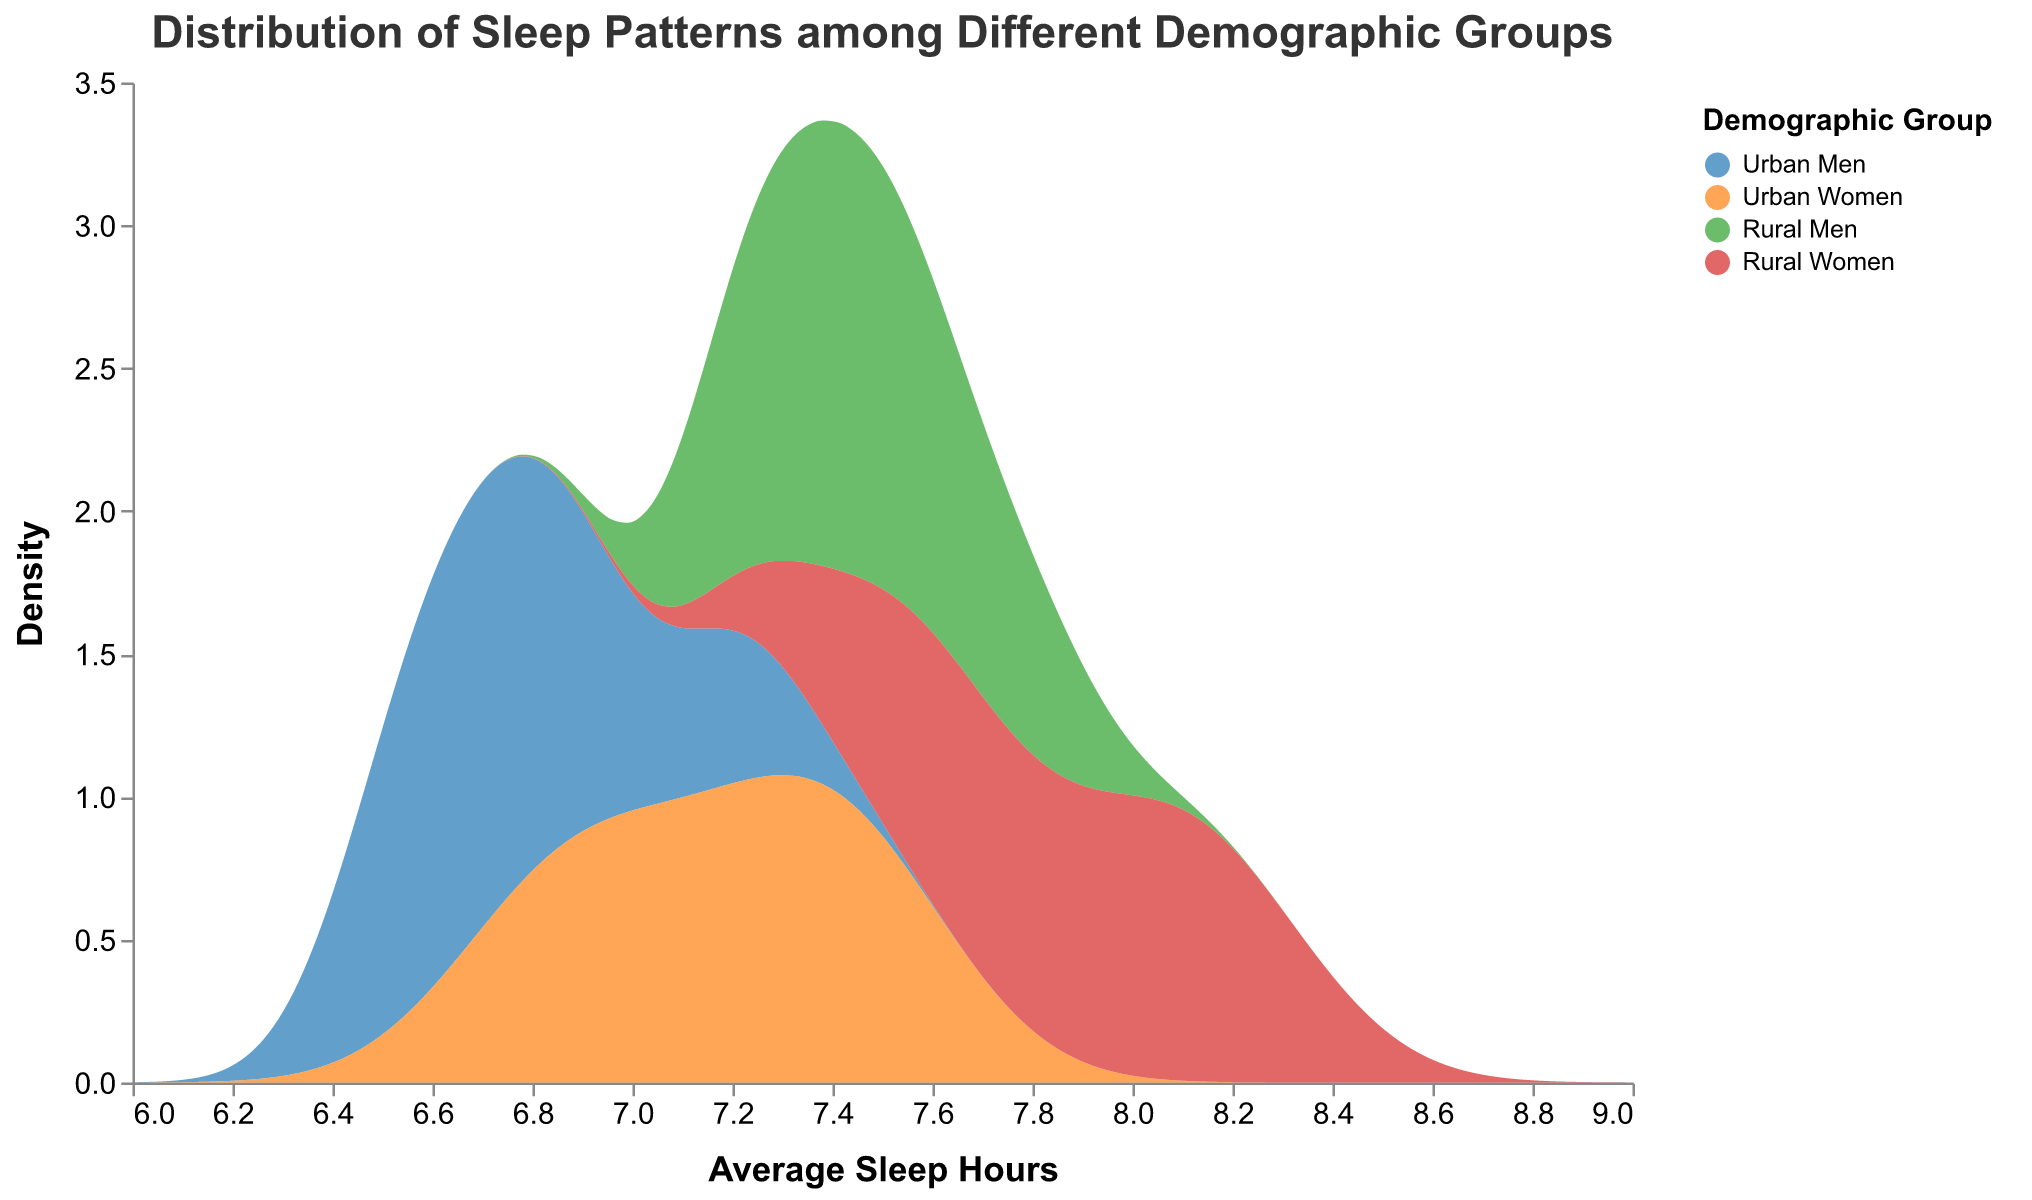What is the title of the plot? The title of the plot is given at the top, typically indicating the main subject of the visualization.
Answer: Distribution of Sleep Patterns among Different Demographic Groups How many demographic groups are represented in the plot? The demographic groups are identified by different colors and are listed in the legend on the right side of the plot.
Answer: Four Which demographic group appears to have the highest average sleep hours? By observing the density peaks on the x-axis, we can determine which group has the highest values. The highest density peak around the high end of sleep hours indicates the group.
Answer: Rural Women Which demographic group shows more density around 6.5 to 7 hours of sleep? To find this, look at the density curves and see which group has higher density in the specified range on the x-axis.
Answer: Urban Men How do sleep patterns of Urban Men compare to Rural Women? Compare the density curves of Urban Men and Rural Women, especially looking at the range of hours where the peaks occur.
Answer: Urban Men generally sleep less than Rural Women, who sleep more hours on average What is the average sleep hours range displayed in the plot? The x-axis title and ticks represent the range of average sleep hours shown.
Answer: 6 to 9 hours Which demographic group has a broader distribution, Urban Men, or Rural Men? Look at the spread of the density curves for Urban Men and Rural Men to see which one is flatter and wider.
Answer: Rural Men Between which two groups is there the most significant difference in average sleep hours? Compare the peaks of the density plots to identify groups with the most significant disparity in their average sleep hours.
Answer: Urban Men and Rural Women Are there any demographic groups with overlapping sleep pattern distributions? By observing the density curves, check for areas where different demographic group's curves overlap significantly.
Answer: Yes, Urban Men and Urban Women have overlapping distributions By how much do the average sleep hours of Rural Women peak compared to Urban Women? Compare the peak density values of Rural Women and Urban Women on the plot to determine their relative heights.
Answer: Rural Women peak higher compared to Urban Women 